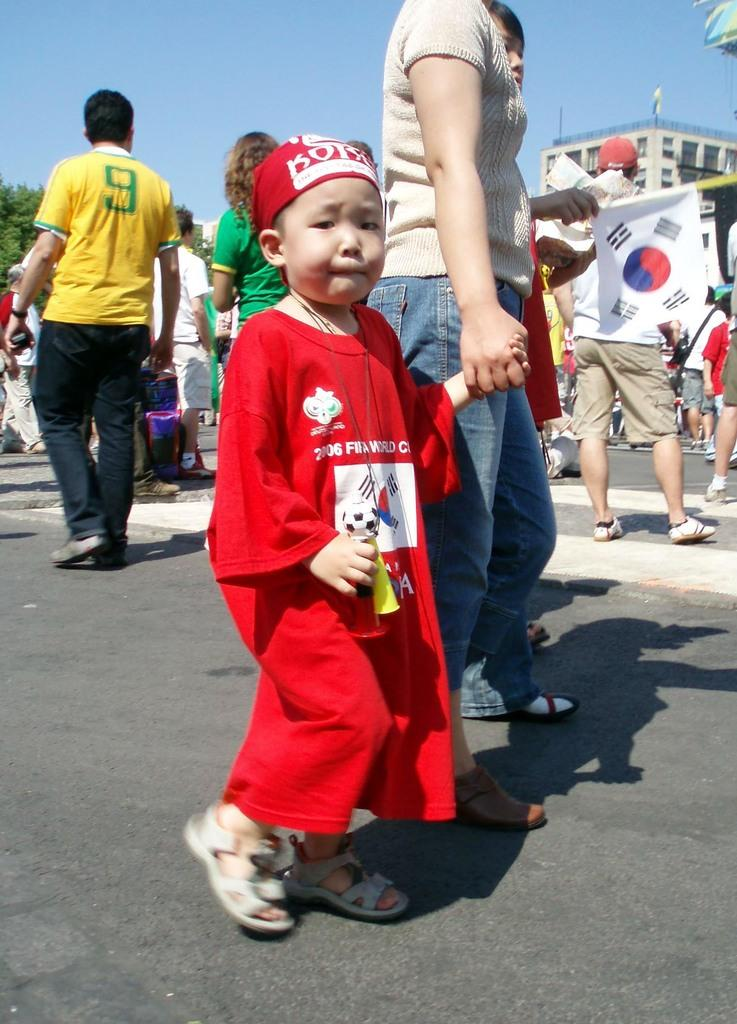What are the people in the image doing? The group of people is standing on the road. What can be seen in the background of the image? There is a building and the sky visible in the background of the image. What is located on the left side of the image? There is a tree on the left side of the image. What type of ring can be seen on the basketball player's finger in the image? There is no basketball player or ring present in the image. What color is the cub that is playing with the people in the image? There is no cub present in the image; it only features a group of people standing on the road. 